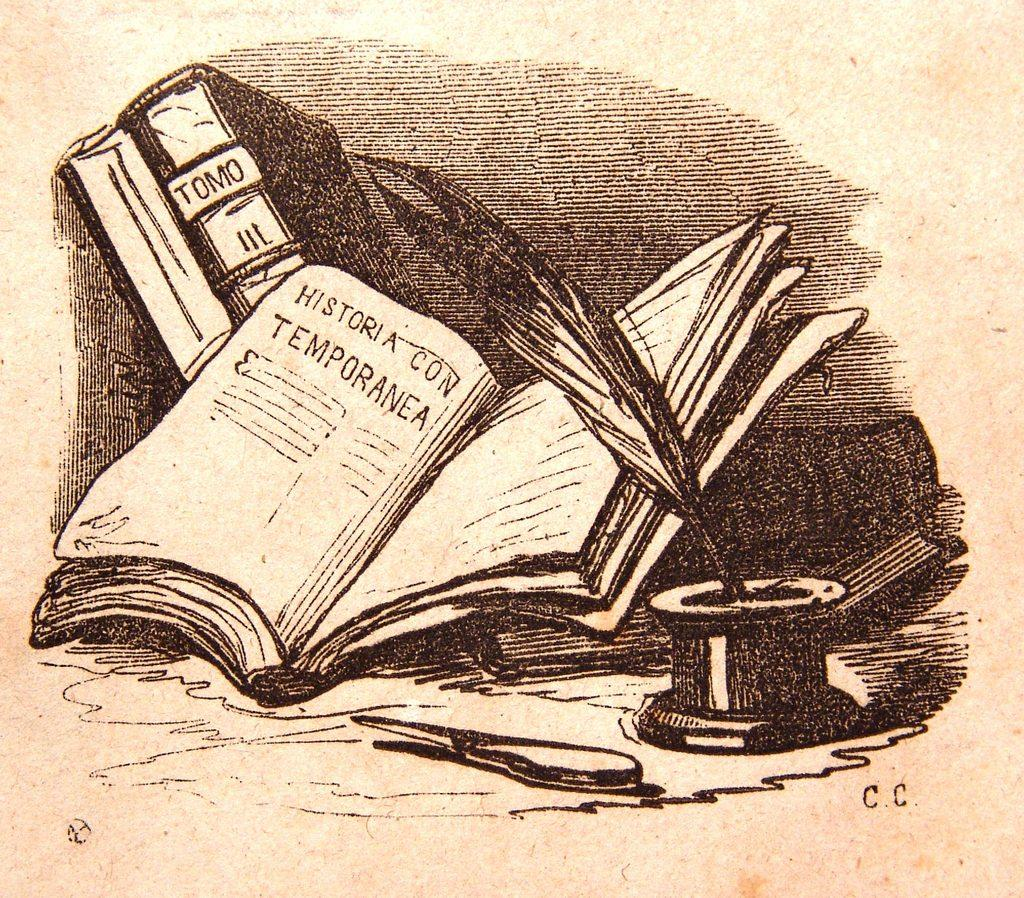What is the main subject in the image? There is a painting in the image. What is the painting on? The painting is on a paper. What type of soap is being used to clean the painting in the image? There is no soap or cleaning activity depicted in the image; it only shows a painting on a paper. 